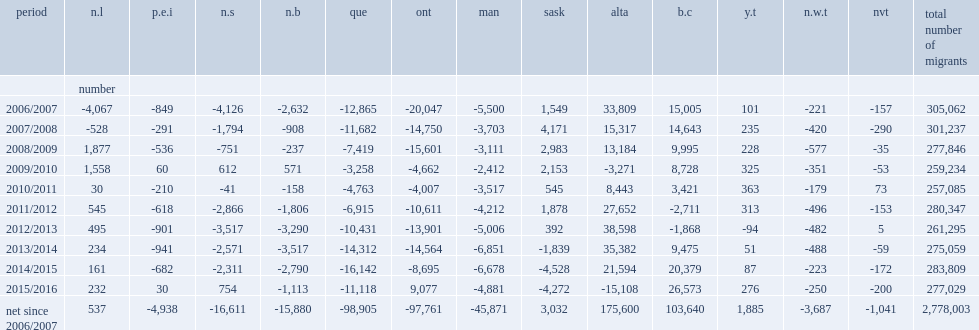Among the five provinces and two territories with negative interprovincial migration in 2015/2016, what percentage of the net loss did alberta account for? 0.408965. Which period marks alberta's first negative net interprovincial migration since 2009/2010? 2015/2016. What was the difference in alberta's net interprovincial migration between the 2014/2015 and 2015/2016 annual periods? 36702. In 2015/2016, which province posted the second largest negative net interprovincial migration in canada? Que. Among the five provinces and one territory with positive interprovincial migration, which two accounted for most of these gains in 2015/2016? B.c ont. What were british columbia's largest net interprovincial migrants since 1994/1995? 26573.0. Which annual period was the first since 2002/2003 in which ontario recorded positive net interprovincial migration? 2015/2016. Parse the table in full. {'header': ['period', 'n.l', 'p.e.i', 'n.s', 'n.b', 'que', 'ont', 'man', 'sask', 'alta', 'b.c', 'y.t', 'n.w.t', 'nvt', 'total number of migrants'], 'rows': [['', 'number', '', '', '', '', '', '', '', '', '', '', '', '', ''], ['2006/2007', '-4,067', '-849', '-4,126', '-2,632', '-12,865', '-20,047', '-5,500', '1,549', '33,809', '15,005', '101', '-221', '-157', '305,062'], ['2007/2008', '-528', '-291', '-1,794', '-908', '-11,682', '-14,750', '-3,703', '4,171', '15,317', '14,643', '235', '-420', '-290', '301,237'], ['2008/2009', '1,877', '-536', '-751', '-237', '-7,419', '-15,601', '-3,111', '2,983', '13,184', '9,995', '228', '-577', '-35', '277,846'], ['2009/2010', '1,558', '60', '612', '571', '-3,258', '-4,662', '-2,412', '2,153', '-3,271', '8,728', '325', '-351', '-53', '259,234'], ['2010/2011', '30', '-210', '-41', '-158', '-4,763', '-4,007', '-3,517', '545', '8,443', '3,421', '363', '-179', '73', '257,085'], ['2011/2012', '545', '-618', '-2,866', '-1,806', '-6,915', '-10,611', '-4,212', '1,878', '27,652', '-2,711', '313', '-496', '-153', '280,347'], ['2012/2013', '495', '-901', '-3,517', '-3,290', '-10,431', '-13,901', '-5,006', '392', '38,598', '-1,868', '-94', '-482', '5', '261,295'], ['2013/2014', '234', '-941', '-2,571', '-3,517', '-14,312', '-14,564', '-6,851', '-1,839', '35,382', '9,475', '51', '-488', '-59', '275,059'], ['2014/2015', '161', '-682', '-2,311', '-2,790', '-16,142', '-8,695', '-6,678', '-4,528', '21,594', '20,379', '87', '-223', '-172', '283,809'], ['2015/2016', '232', '30', '754', '-1,113', '-11,118', '9,077', '-4,881', '-4,272', '-15,108', '26,573', '276', '-250', '-200', '277,029'], ['net since 2006/2007', '537', '-4,938', '-16,611', '-15,880', '-98,905', '-97,761', '-45,871', '3,032', '175,600', '103,640', '1,885', '-3,687', '-1,041', '2,778,003']]} 